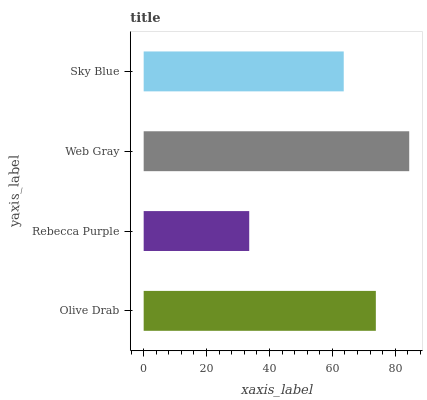Is Rebecca Purple the minimum?
Answer yes or no. Yes. Is Web Gray the maximum?
Answer yes or no. Yes. Is Web Gray the minimum?
Answer yes or no. No. Is Rebecca Purple the maximum?
Answer yes or no. No. Is Web Gray greater than Rebecca Purple?
Answer yes or no. Yes. Is Rebecca Purple less than Web Gray?
Answer yes or no. Yes. Is Rebecca Purple greater than Web Gray?
Answer yes or no. No. Is Web Gray less than Rebecca Purple?
Answer yes or no. No. Is Olive Drab the high median?
Answer yes or no. Yes. Is Sky Blue the low median?
Answer yes or no. Yes. Is Sky Blue the high median?
Answer yes or no. No. Is Olive Drab the low median?
Answer yes or no. No. 